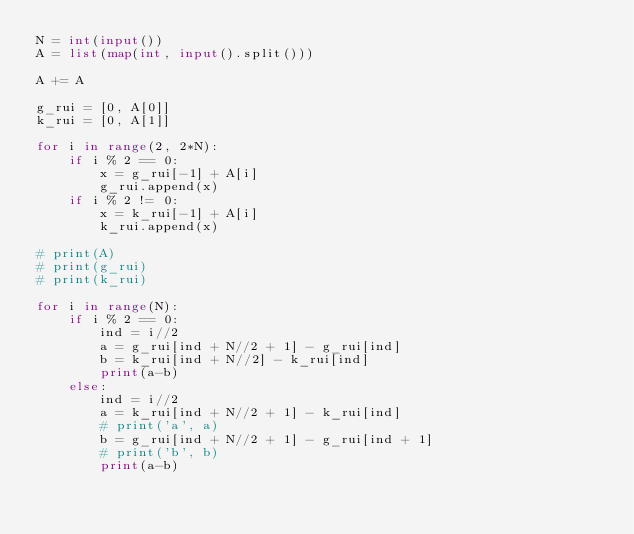Convert code to text. <code><loc_0><loc_0><loc_500><loc_500><_Python_>N = int(input())
A = list(map(int, input().split()))

A += A

g_rui = [0, A[0]]
k_rui = [0, A[1]]

for i in range(2, 2*N):
    if i % 2 == 0:
        x = g_rui[-1] + A[i]
        g_rui.append(x)
    if i % 2 != 0:
        x = k_rui[-1] + A[i]
        k_rui.append(x)

# print(A)
# print(g_rui)
# print(k_rui)

for i in range(N):
    if i % 2 == 0:
        ind = i//2
        a = g_rui[ind + N//2 + 1] - g_rui[ind]
        b = k_rui[ind + N//2] - k_rui[ind]
        print(a-b)
    else:
        ind = i//2
        a = k_rui[ind + N//2 + 1] - k_rui[ind]
        # print('a', a)
        b = g_rui[ind + N//2 + 1] - g_rui[ind + 1]
        # print('b', b)
        print(a-b)    

</code> 